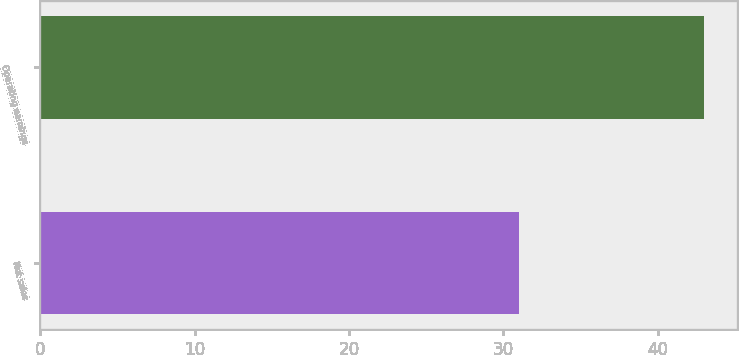Convert chart. <chart><loc_0><loc_0><loc_500><loc_500><bar_chart><fcel>Net sales<fcel>Operating earnings<nl><fcel>31<fcel>43<nl></chart> 